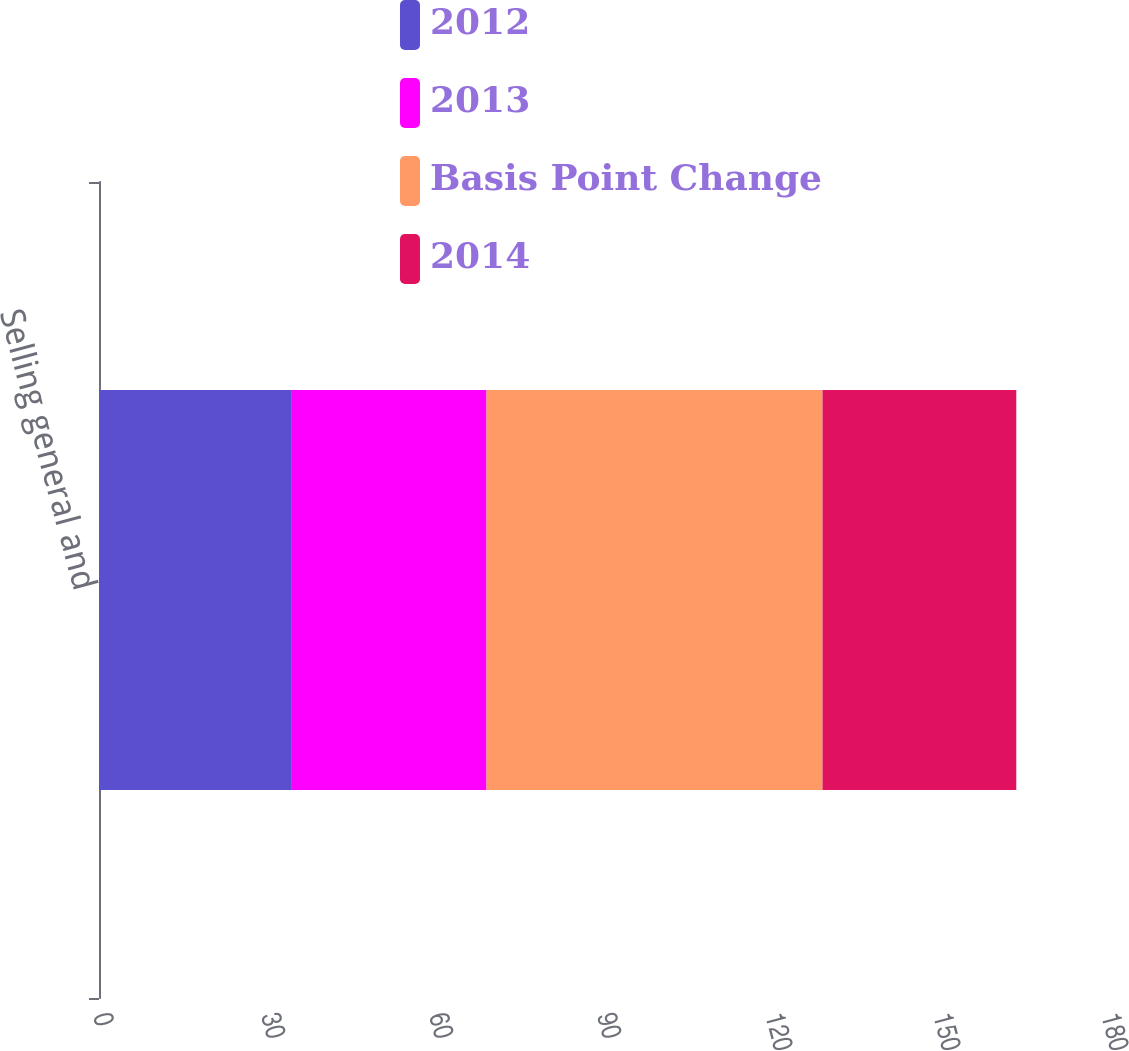Convert chart to OTSL. <chart><loc_0><loc_0><loc_500><loc_500><stacked_bar_chart><ecel><fcel>Selling general and<nl><fcel>2012<fcel>34.3<nl><fcel>2013<fcel>34.9<nl><fcel>Basis Point Change<fcel>60<nl><fcel>2014<fcel>34.6<nl></chart> 